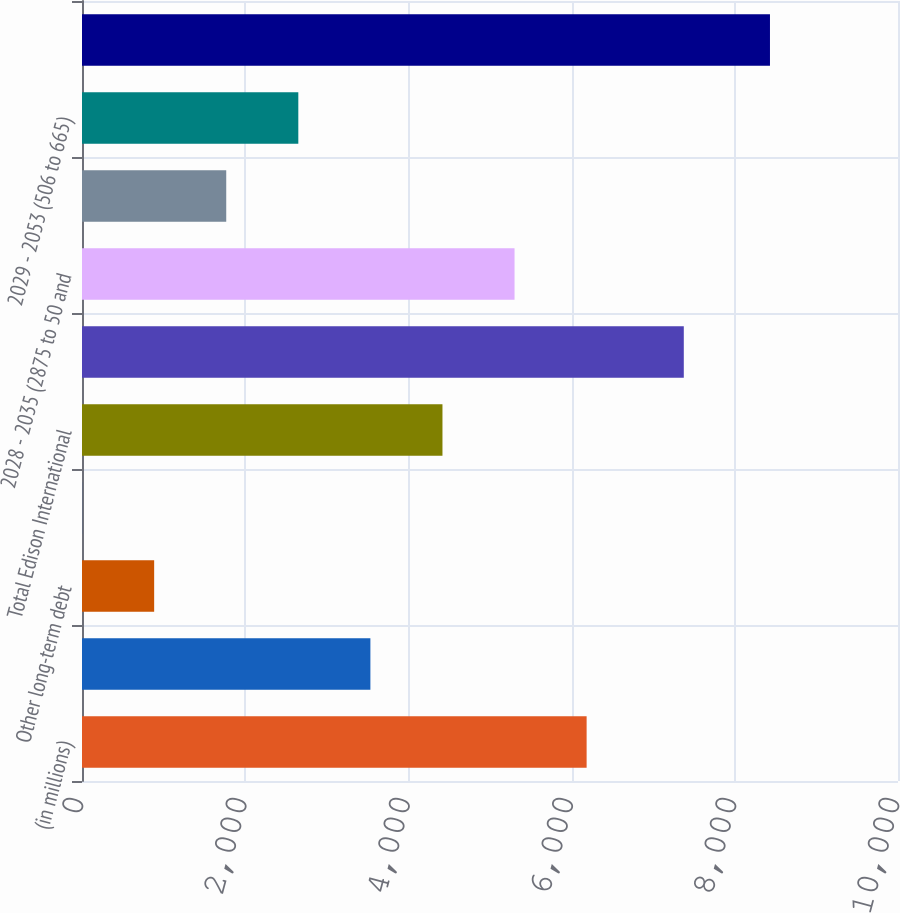Convert chart. <chart><loc_0><loc_0><loc_500><loc_500><bar_chart><fcel>(in millions)<fcel>2017 (375)<fcel>Other long-term debt<fcel>Unamortized debt discount net<fcel>Total Edison International<fcel>2014 - 2042 (3875 to 605 and<fcel>2028 - 2035 (2875 to 50 and<fcel>Bonds repurchased<fcel>2029 - 2053 (506 to 665)<fcel>Total SCE<nl><fcel>6184.1<fcel>3534.2<fcel>884.3<fcel>1<fcel>4417.5<fcel>7375<fcel>5300.8<fcel>1767.6<fcel>2650.9<fcel>8431<nl></chart> 